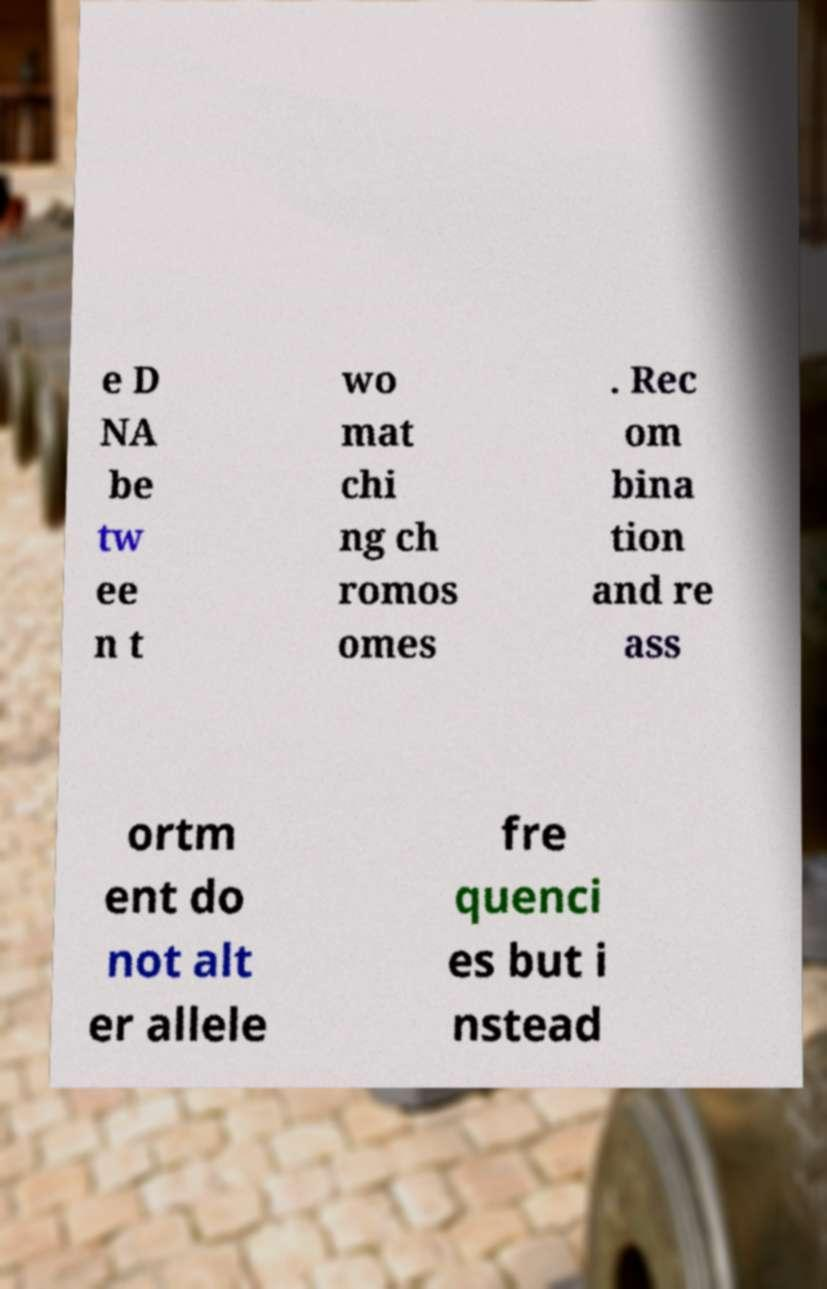Could you extract and type out the text from this image? e D NA be tw ee n t wo mat chi ng ch romos omes . Rec om bina tion and re ass ortm ent do not alt er allele fre quenci es but i nstead 